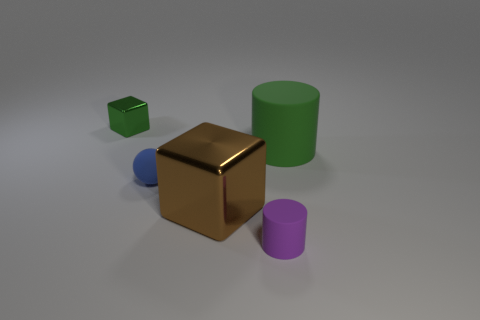Add 4 small purple shiny cubes. How many objects exist? 9 Subtract all blue cubes. How many green cylinders are left? 1 Subtract 0 yellow cylinders. How many objects are left? 5 Subtract all cubes. How many objects are left? 3 Subtract 1 cylinders. How many cylinders are left? 1 Subtract all yellow cubes. Subtract all brown cylinders. How many cubes are left? 2 Subtract all tiny purple cylinders. Subtract all tiny blue balls. How many objects are left? 3 Add 3 tiny green metal objects. How many tiny green metal objects are left? 4 Add 5 big green matte spheres. How many big green matte spheres exist? 5 